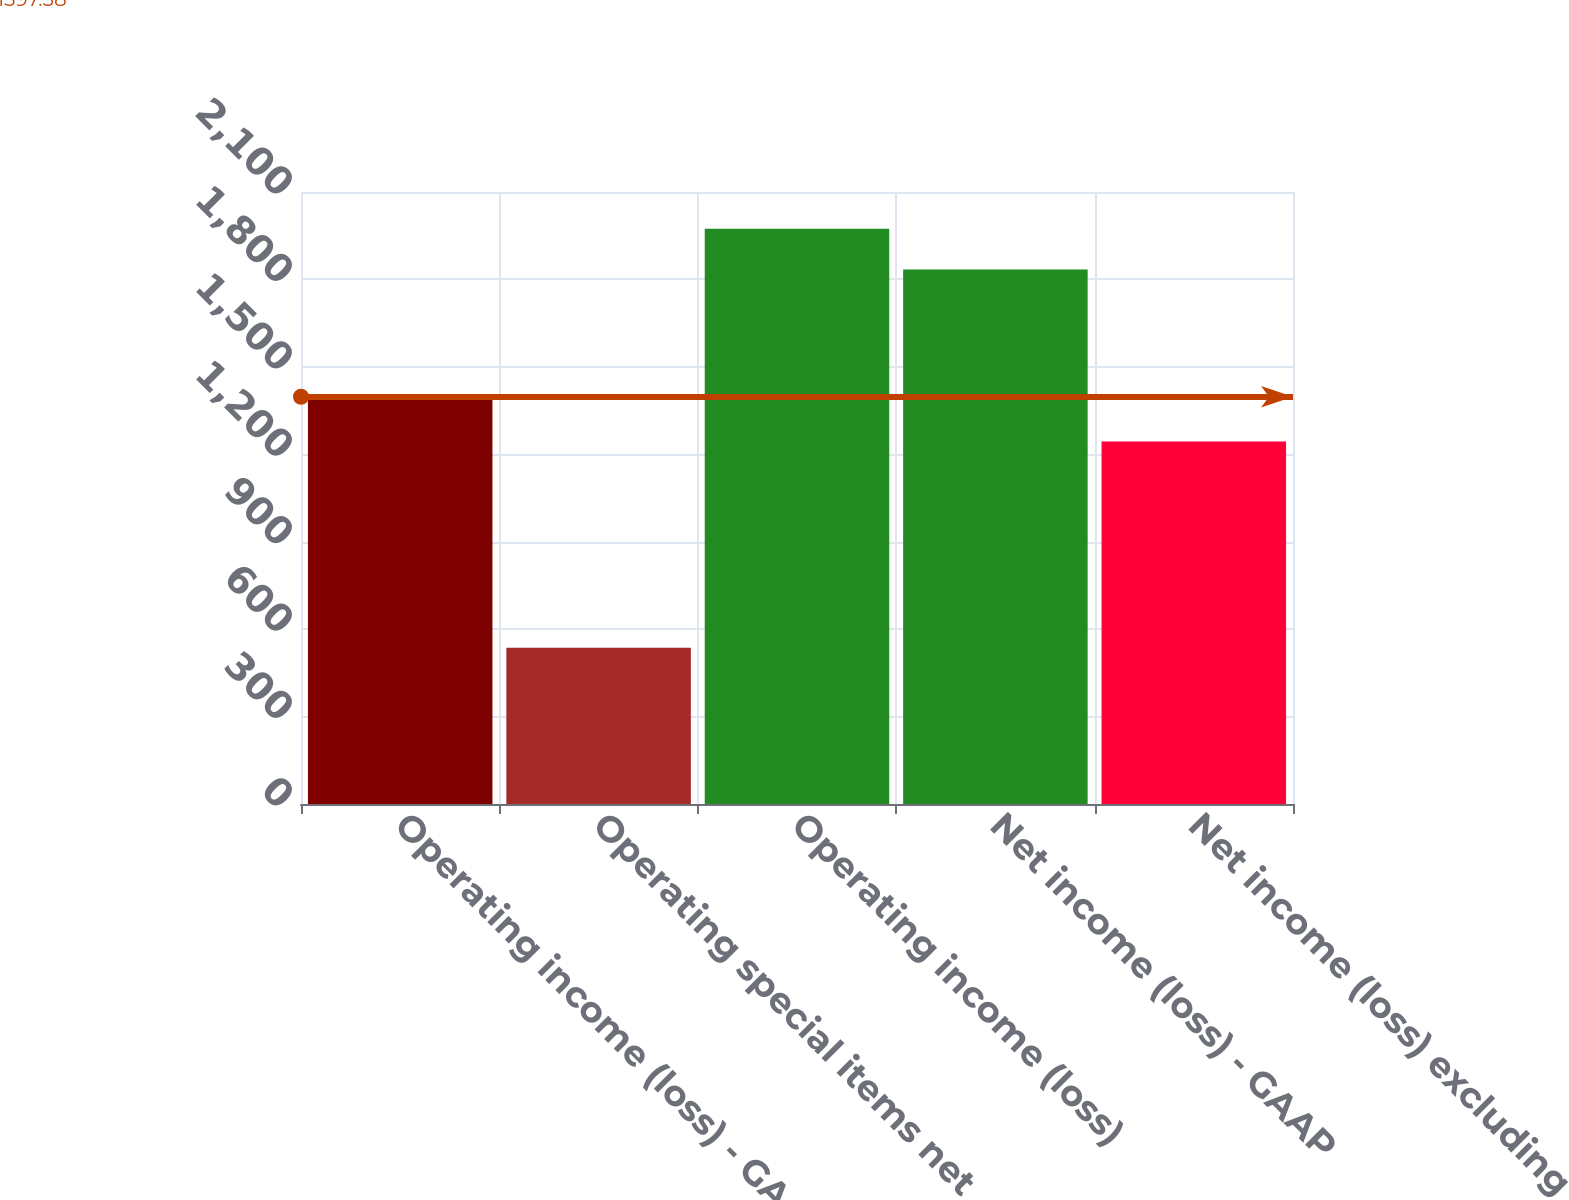Convert chart to OTSL. <chart><loc_0><loc_0><loc_500><loc_500><bar_chart><fcel>Operating income (loss) - GAAP<fcel>Operating special items net<fcel>Operating income (loss)<fcel>Net income (loss) - GAAP<fcel>Net income (loss) excluding<nl><fcel>1399<fcel>536<fcel>1973.9<fcel>1834<fcel>1244<nl></chart> 